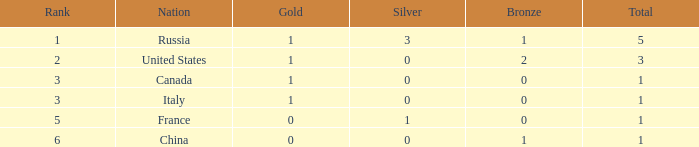Name the total number of golds when total is 1 and silver is 1 1.0. 